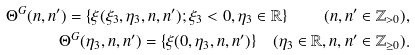<formula> <loc_0><loc_0><loc_500><loc_500>\Theta ^ { G } ( n , n ^ { \prime } ) = \{ \xi ( \xi _ { 3 } , \eta _ { 3 } , n , n ^ { \prime } ) ; \xi _ { 3 } < 0 , \eta _ { 3 } \in \mathbb { R } \} \quad ( n , n ^ { \prime } \in \mathbb { Z } _ { > 0 } ) , \\ \Theta ^ { G } ( \eta _ { 3 } , n , n ^ { \prime } ) = \{ \xi ( 0 , \eta _ { 3 } , n , n ^ { \prime } ) \} \quad ( \eta _ { 3 } \in \mathbb { R } , n , n ^ { \prime } \in \mathbb { Z } _ { \geq 0 } ) .</formula> 